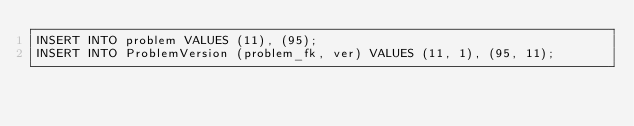Convert code to text. <code><loc_0><loc_0><loc_500><loc_500><_SQL_>INSERT INTO problem VALUES (11), (95);
INSERT INTO ProblemVersion (problem_fk, ver) VALUES (11, 1), (95, 11); 
</code> 